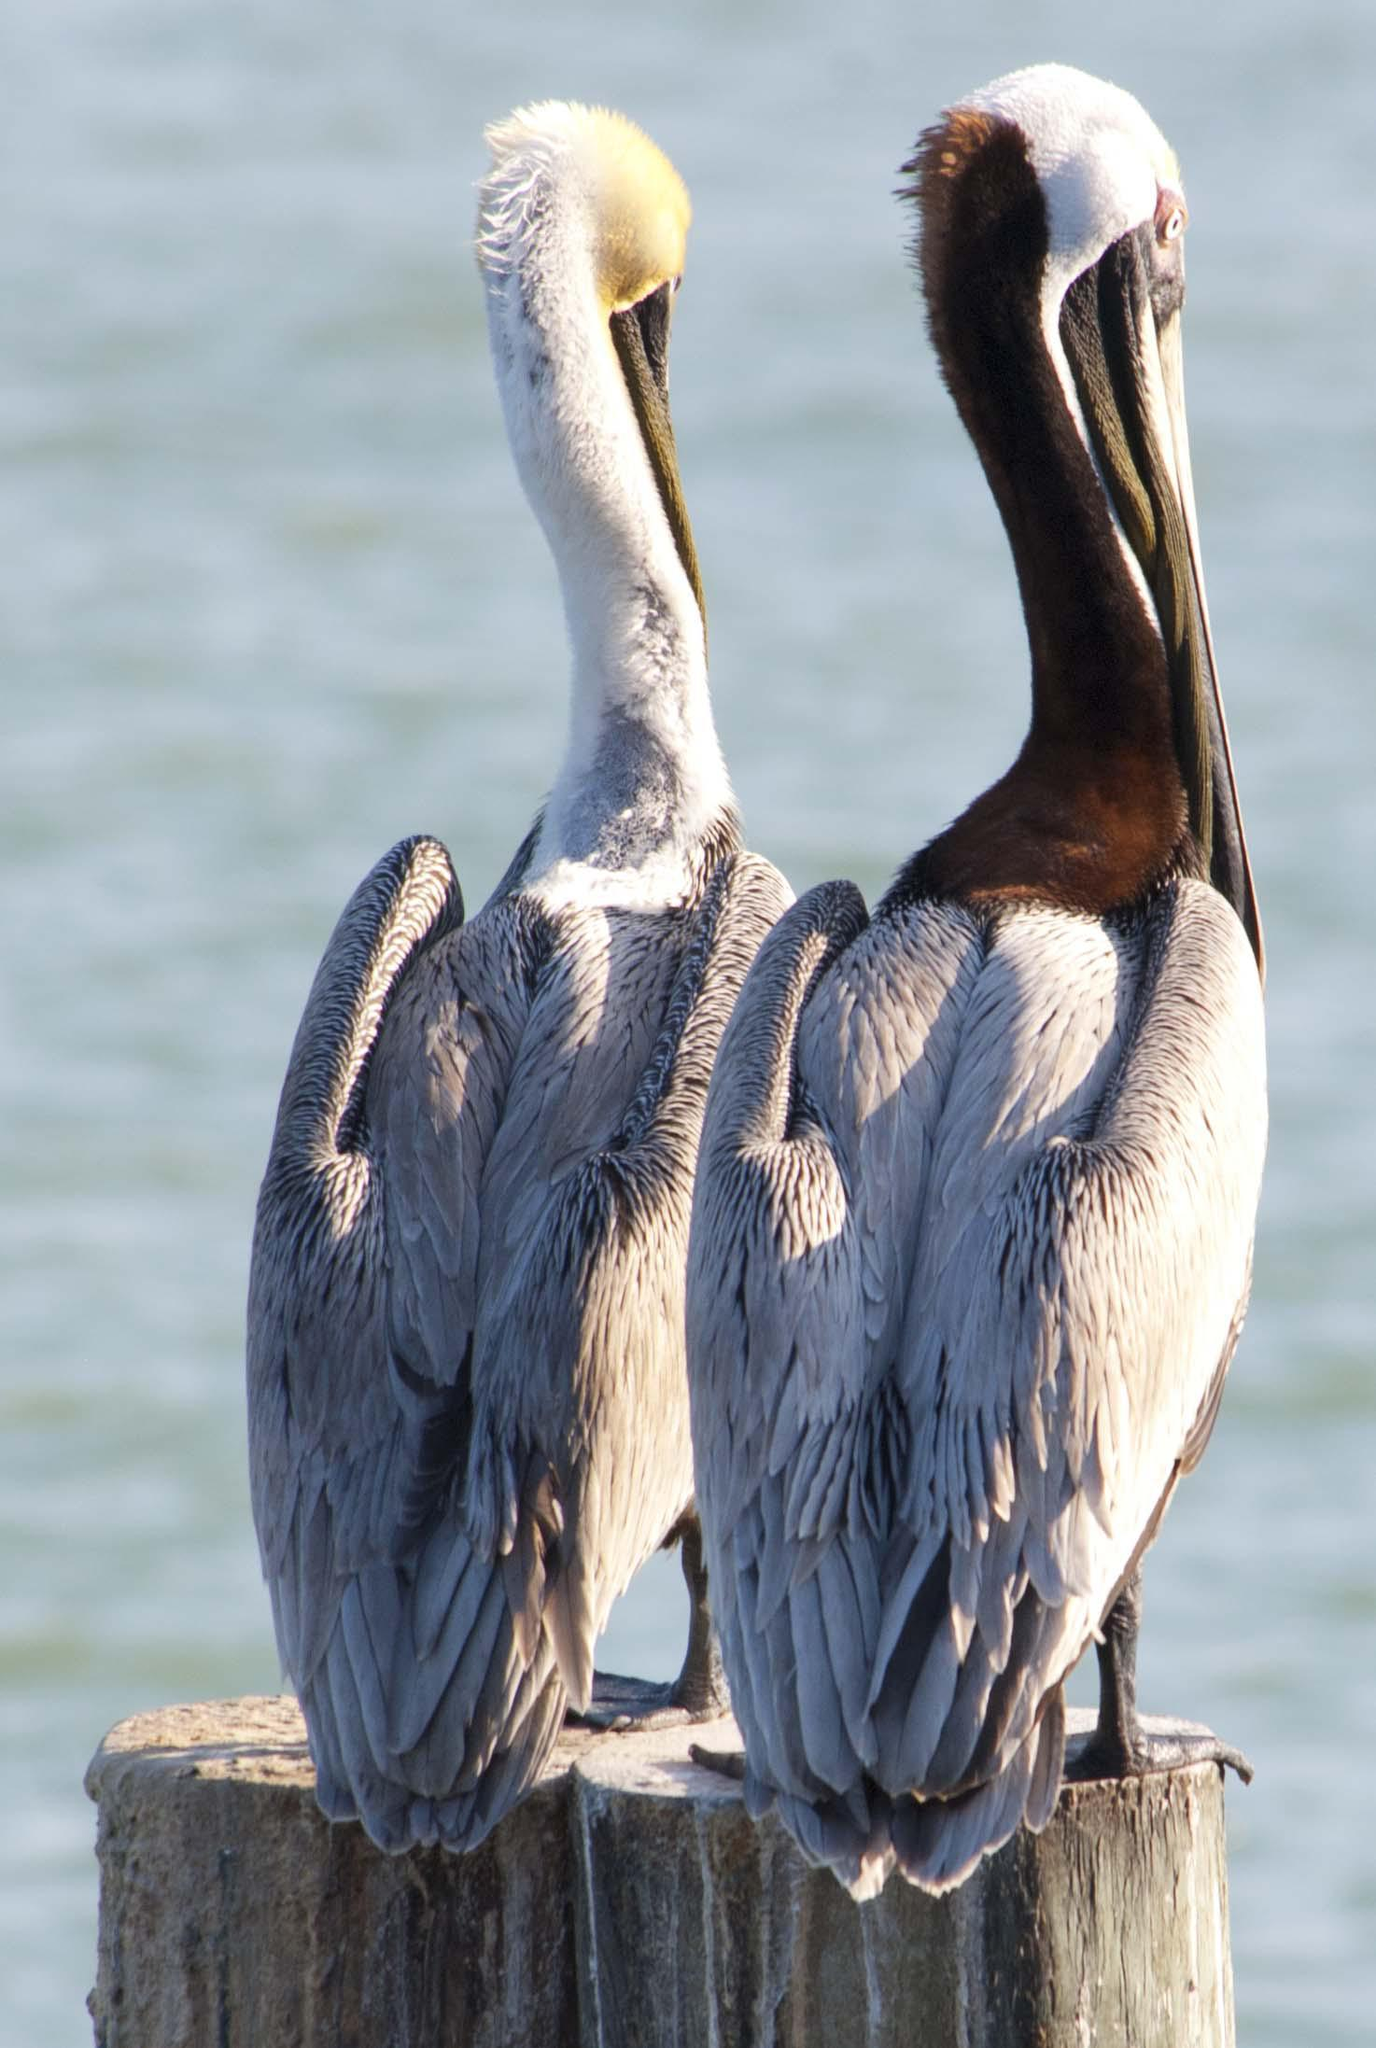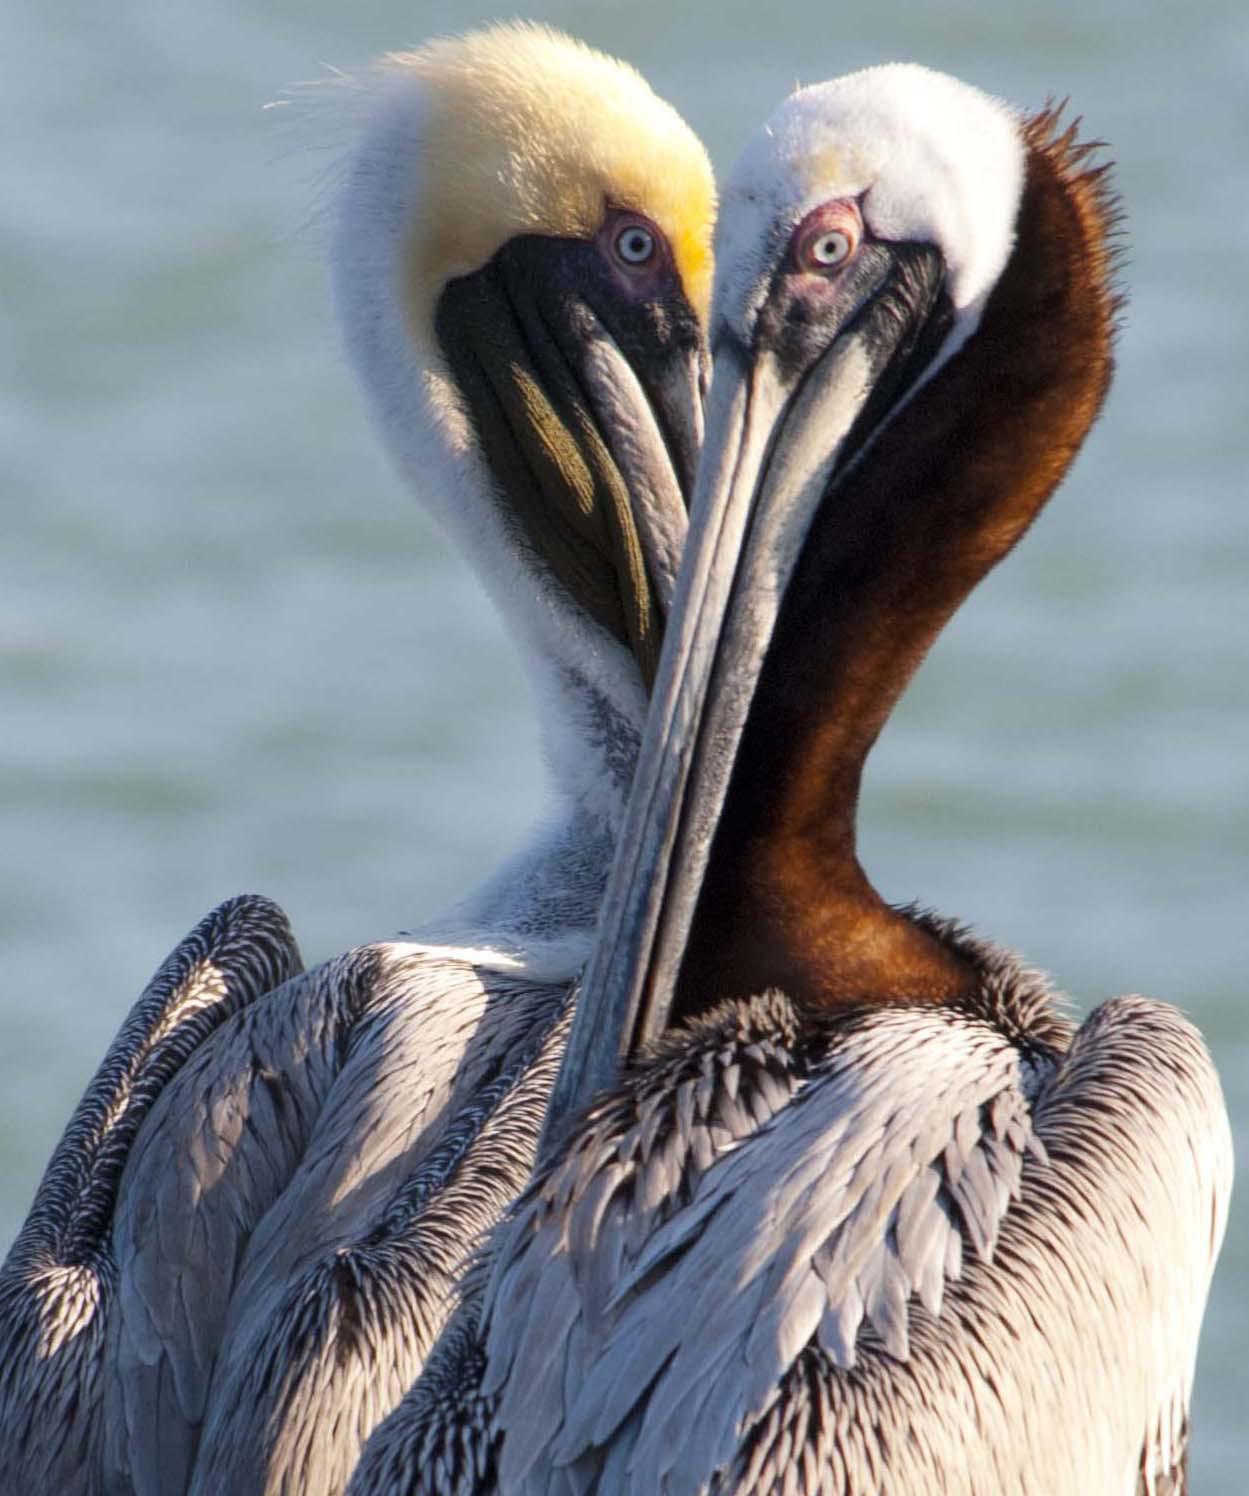The first image is the image on the left, the second image is the image on the right. Examine the images to the left and right. Is the description "Two birds are perched on a post in one of the images." accurate? Answer yes or no. Yes. The first image is the image on the left, the second image is the image on the right. Evaluate the accuracy of this statement regarding the images: "An image shows only two birds, which are overlapped facing each other so their heads and necks form a heart shape.". Is it true? Answer yes or no. Yes. 